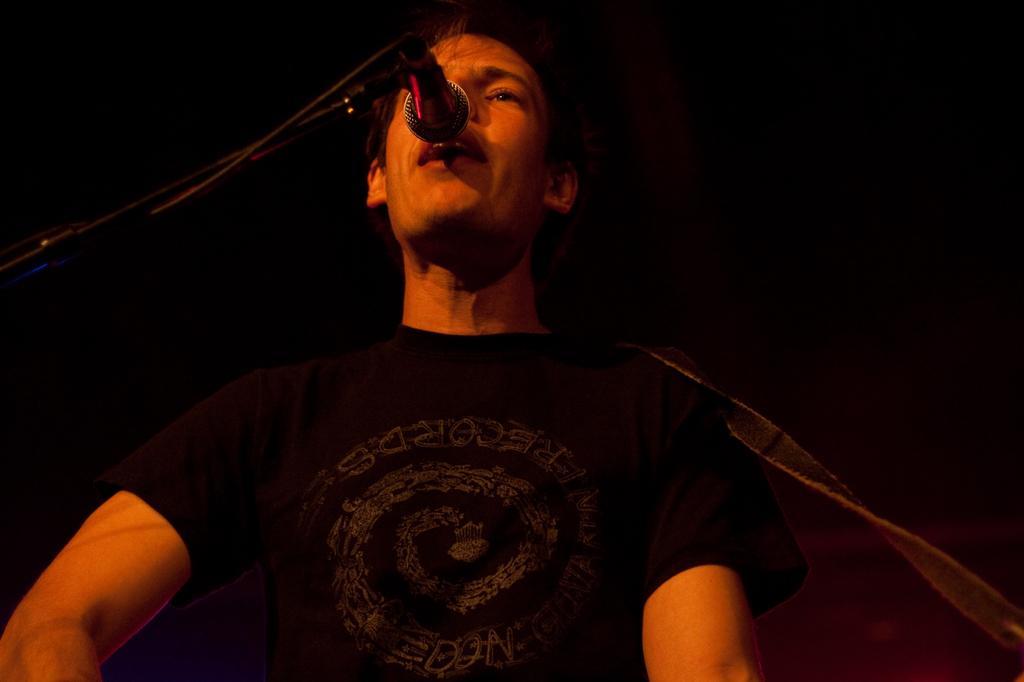Please provide a concise description of this image. In this image person is singing a song and in front of him there is a mike. 